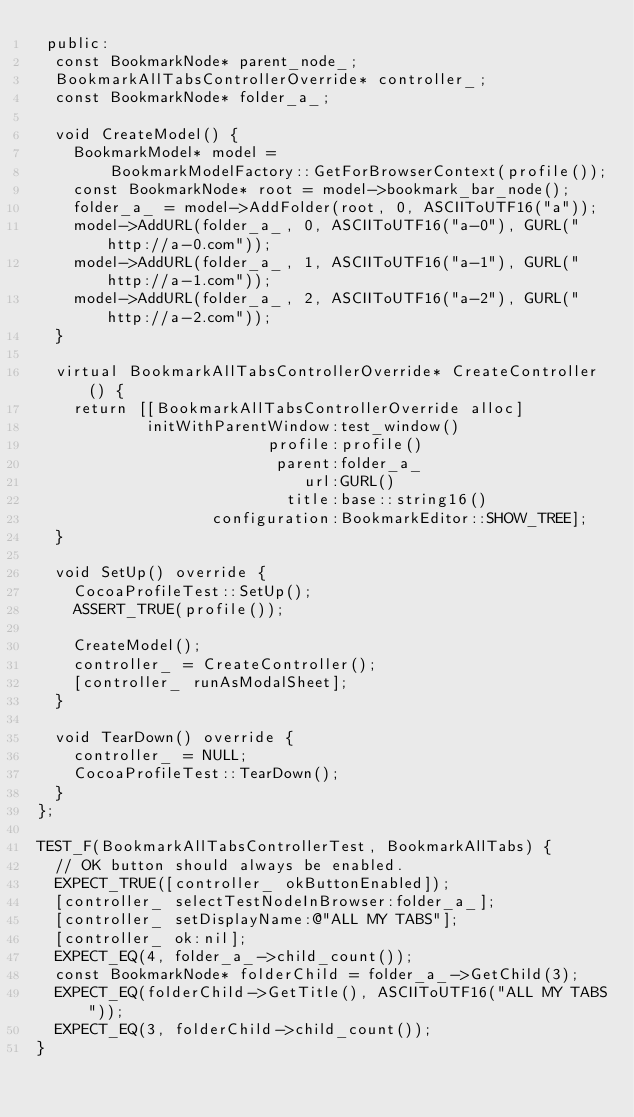Convert code to text. <code><loc_0><loc_0><loc_500><loc_500><_ObjectiveC_> public:
  const BookmarkNode* parent_node_;
  BookmarkAllTabsControllerOverride* controller_;
  const BookmarkNode* folder_a_;

  void CreateModel() {
    BookmarkModel* model =
        BookmarkModelFactory::GetForBrowserContext(profile());
    const BookmarkNode* root = model->bookmark_bar_node();
    folder_a_ = model->AddFolder(root, 0, ASCIIToUTF16("a"));
    model->AddURL(folder_a_, 0, ASCIIToUTF16("a-0"), GURL("http://a-0.com"));
    model->AddURL(folder_a_, 1, ASCIIToUTF16("a-1"), GURL("http://a-1.com"));
    model->AddURL(folder_a_, 2, ASCIIToUTF16("a-2"), GURL("http://a-2.com"));
  }

  virtual BookmarkAllTabsControllerOverride* CreateController() {
    return [[BookmarkAllTabsControllerOverride alloc]
            initWithParentWindow:test_window()
                         profile:profile()
                          parent:folder_a_
                             url:GURL()
                           title:base::string16()
                   configuration:BookmarkEditor::SHOW_TREE];
  }

  void SetUp() override {
    CocoaProfileTest::SetUp();
    ASSERT_TRUE(profile());

    CreateModel();
    controller_ = CreateController();
    [controller_ runAsModalSheet];
  }

  void TearDown() override {
    controller_ = NULL;
    CocoaProfileTest::TearDown();
  }
};

TEST_F(BookmarkAllTabsControllerTest, BookmarkAllTabs) {
  // OK button should always be enabled.
  EXPECT_TRUE([controller_ okButtonEnabled]);
  [controller_ selectTestNodeInBrowser:folder_a_];
  [controller_ setDisplayName:@"ALL MY TABS"];
  [controller_ ok:nil];
  EXPECT_EQ(4, folder_a_->child_count());
  const BookmarkNode* folderChild = folder_a_->GetChild(3);
  EXPECT_EQ(folderChild->GetTitle(), ASCIIToUTF16("ALL MY TABS"));
  EXPECT_EQ(3, folderChild->child_count());
}
</code> 